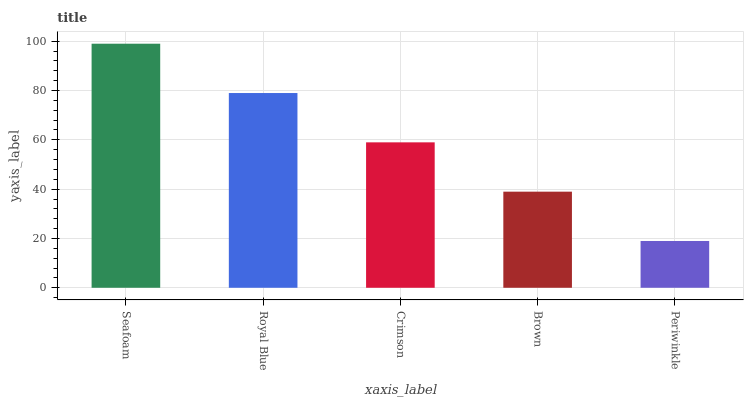Is Periwinkle the minimum?
Answer yes or no. Yes. Is Seafoam the maximum?
Answer yes or no. Yes. Is Royal Blue the minimum?
Answer yes or no. No. Is Royal Blue the maximum?
Answer yes or no. No. Is Seafoam greater than Royal Blue?
Answer yes or no. Yes. Is Royal Blue less than Seafoam?
Answer yes or no. Yes. Is Royal Blue greater than Seafoam?
Answer yes or no. No. Is Seafoam less than Royal Blue?
Answer yes or no. No. Is Crimson the high median?
Answer yes or no. Yes. Is Crimson the low median?
Answer yes or no. Yes. Is Brown the high median?
Answer yes or no. No. Is Royal Blue the low median?
Answer yes or no. No. 